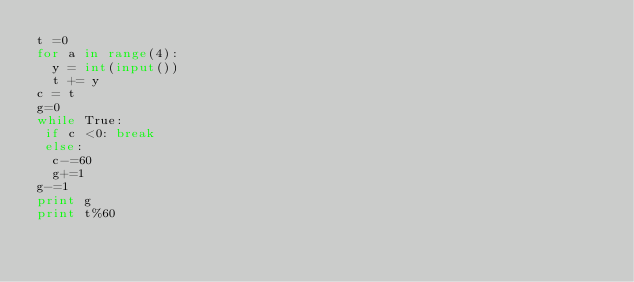<code> <loc_0><loc_0><loc_500><loc_500><_Python_>t =0
for a in range(4):
  y = int(input())
  t += y
c = t
g=0
while True:
 if c <0: break
 else:
  c-=60
  g+=1
g-=1
print g
print t%60</code> 